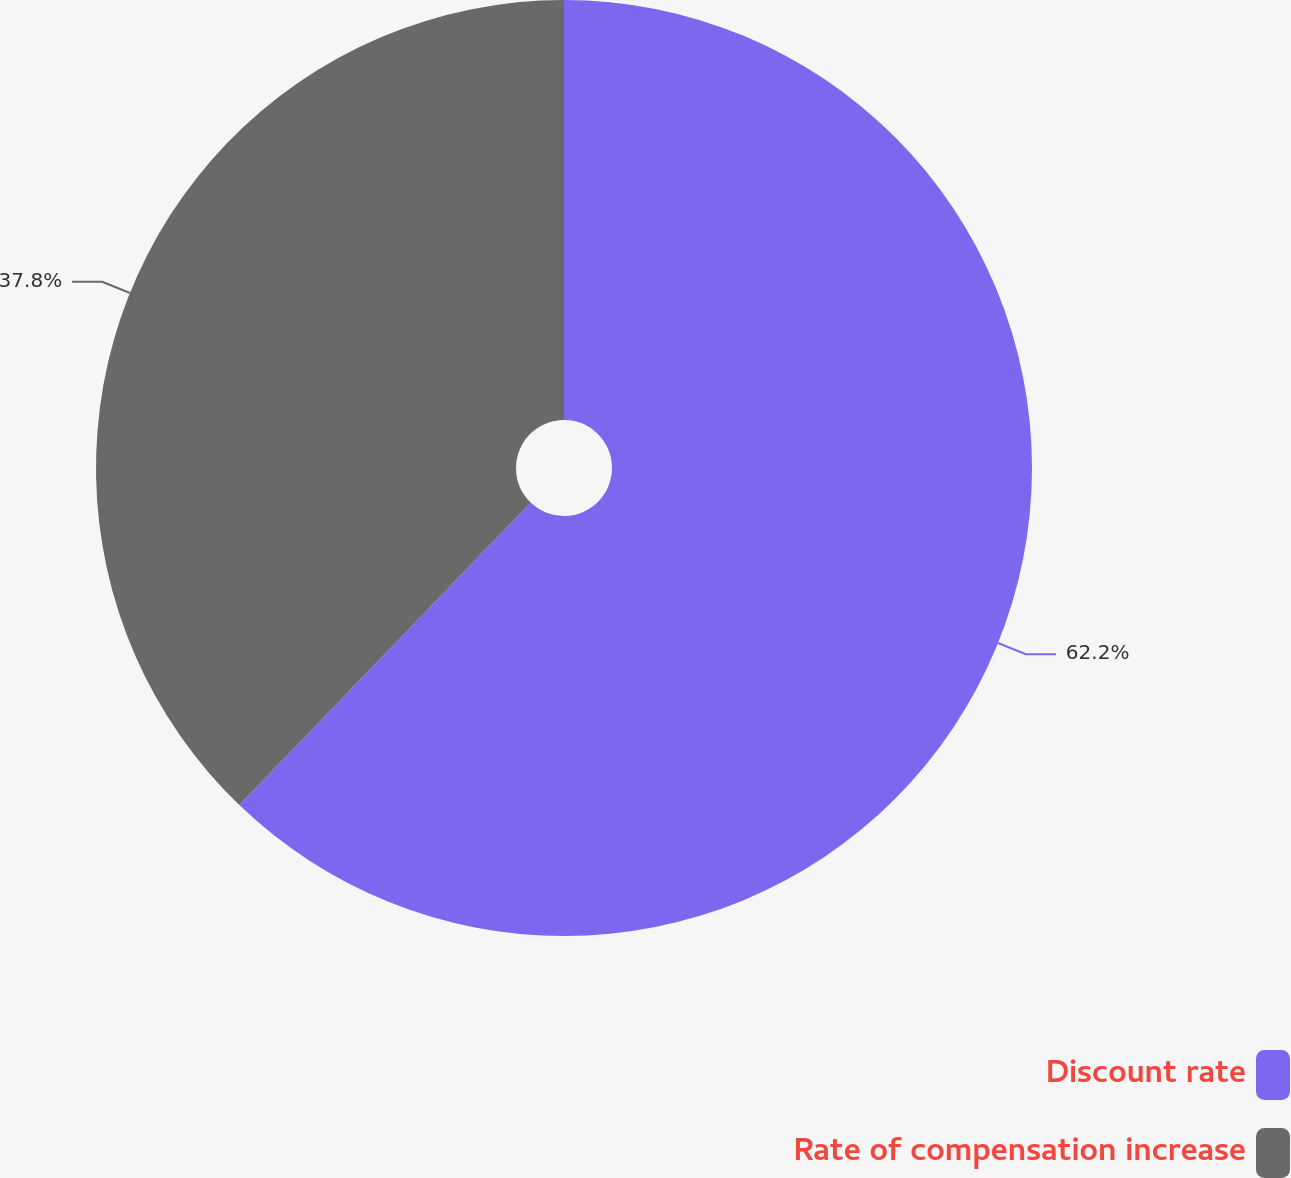<chart> <loc_0><loc_0><loc_500><loc_500><pie_chart><fcel>Discount rate<fcel>Rate of compensation increase<nl><fcel>62.2%<fcel>37.8%<nl></chart> 